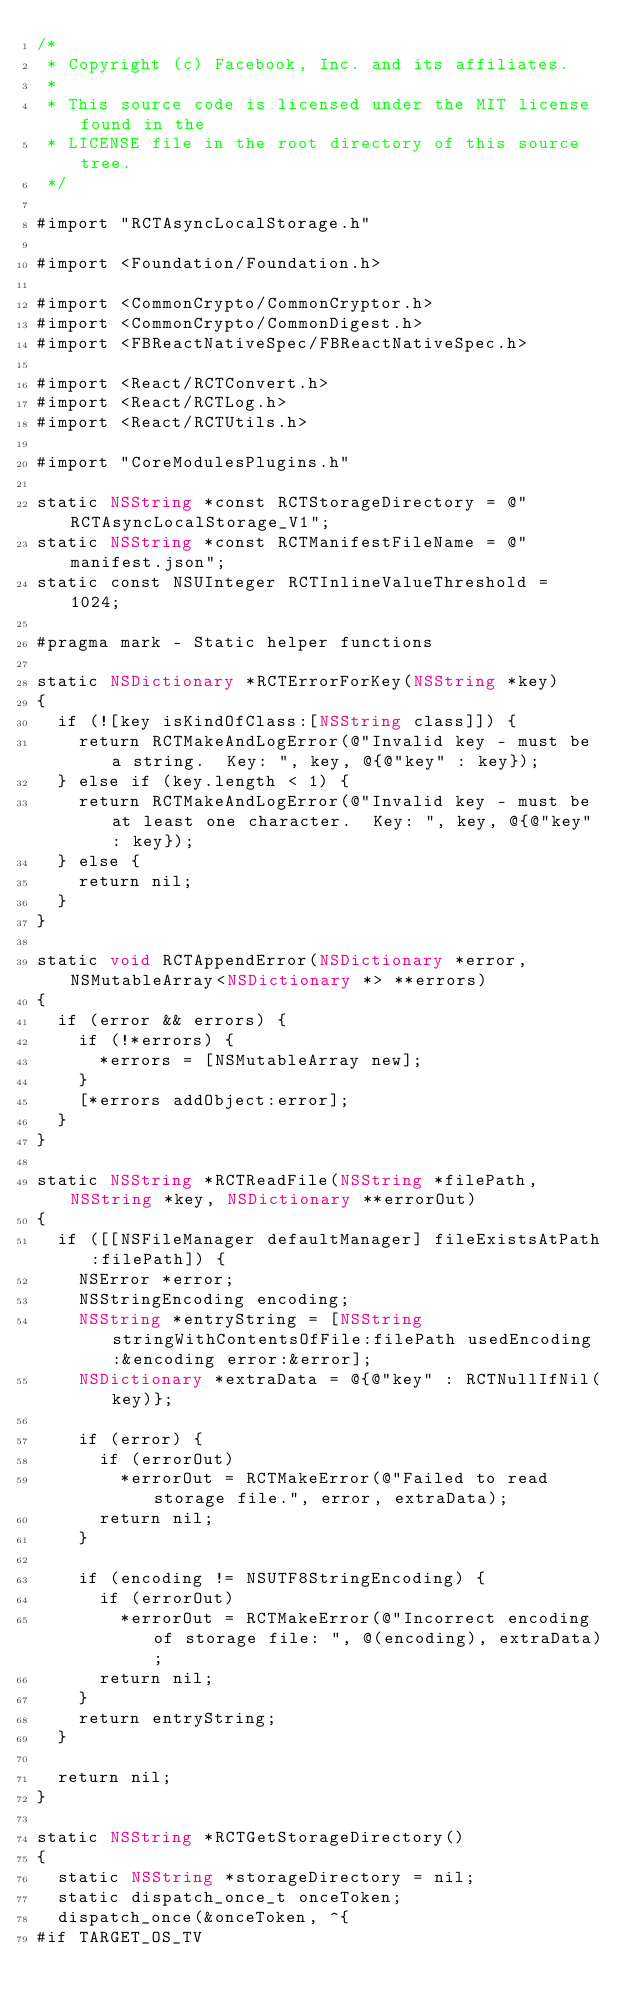Convert code to text. <code><loc_0><loc_0><loc_500><loc_500><_ObjectiveC_>/*
 * Copyright (c) Facebook, Inc. and its affiliates.
 *
 * This source code is licensed under the MIT license found in the
 * LICENSE file in the root directory of this source tree.
 */

#import "RCTAsyncLocalStorage.h"

#import <Foundation/Foundation.h>

#import <CommonCrypto/CommonCryptor.h>
#import <CommonCrypto/CommonDigest.h>
#import <FBReactNativeSpec/FBReactNativeSpec.h>

#import <React/RCTConvert.h>
#import <React/RCTLog.h>
#import <React/RCTUtils.h>

#import "CoreModulesPlugins.h"

static NSString *const RCTStorageDirectory = @"RCTAsyncLocalStorage_V1";
static NSString *const RCTManifestFileName = @"manifest.json";
static const NSUInteger RCTInlineValueThreshold = 1024;

#pragma mark - Static helper functions

static NSDictionary *RCTErrorForKey(NSString *key)
{
  if (![key isKindOfClass:[NSString class]]) {
    return RCTMakeAndLogError(@"Invalid key - must be a string.  Key: ", key, @{@"key" : key});
  } else if (key.length < 1) {
    return RCTMakeAndLogError(@"Invalid key - must be at least one character.  Key: ", key, @{@"key" : key});
  } else {
    return nil;
  }
}

static void RCTAppendError(NSDictionary *error, NSMutableArray<NSDictionary *> **errors)
{
  if (error && errors) {
    if (!*errors) {
      *errors = [NSMutableArray new];
    }
    [*errors addObject:error];
  }
}

static NSString *RCTReadFile(NSString *filePath, NSString *key, NSDictionary **errorOut)
{
  if ([[NSFileManager defaultManager] fileExistsAtPath:filePath]) {
    NSError *error;
    NSStringEncoding encoding;
    NSString *entryString = [NSString stringWithContentsOfFile:filePath usedEncoding:&encoding error:&error];
    NSDictionary *extraData = @{@"key" : RCTNullIfNil(key)};

    if (error) {
      if (errorOut)
        *errorOut = RCTMakeError(@"Failed to read storage file.", error, extraData);
      return nil;
    }

    if (encoding != NSUTF8StringEncoding) {
      if (errorOut)
        *errorOut = RCTMakeError(@"Incorrect encoding of storage file: ", @(encoding), extraData);
      return nil;
    }
    return entryString;
  }

  return nil;
}

static NSString *RCTGetStorageDirectory()
{
  static NSString *storageDirectory = nil;
  static dispatch_once_t onceToken;
  dispatch_once(&onceToken, ^{
#if TARGET_OS_TV</code> 